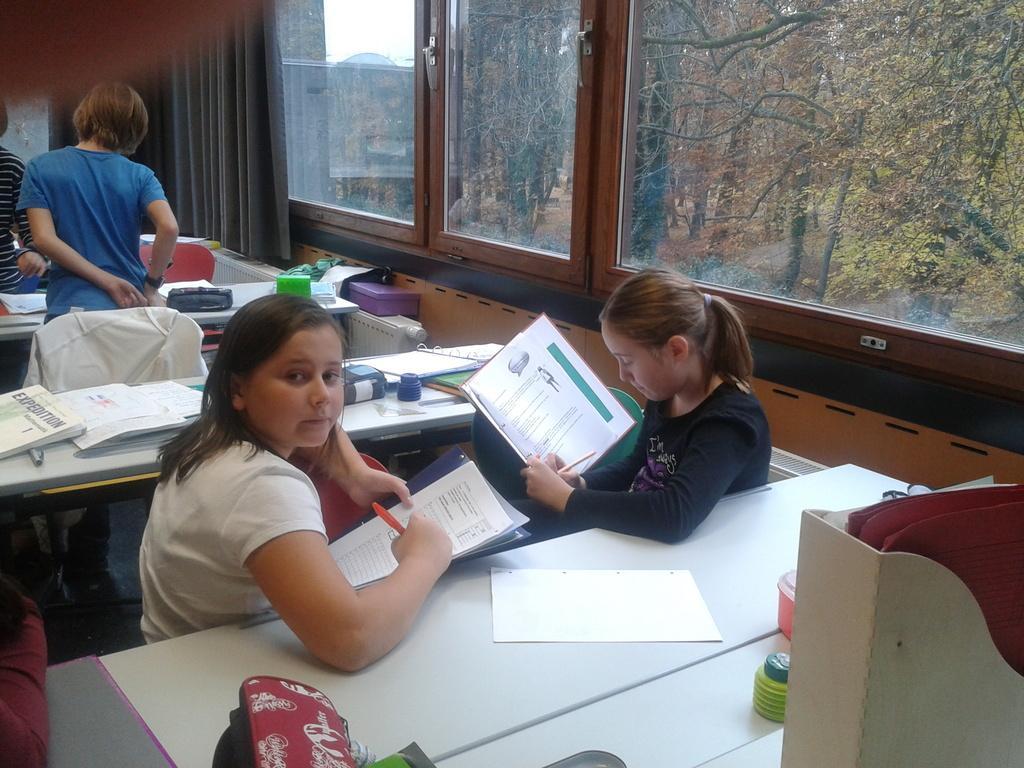Describe this image in one or two sentences. It is a classroom kids are sitting beside the table they are holding the books in their hand to the left of them two kids are standing in the background there is a window and outside the window there are some trees and sky. 